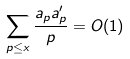Convert formula to latex. <formula><loc_0><loc_0><loc_500><loc_500>\sum _ { p \leq x } \frac { a _ { p } a _ { p } ^ { \prime } } { p } = O ( 1 )</formula> 